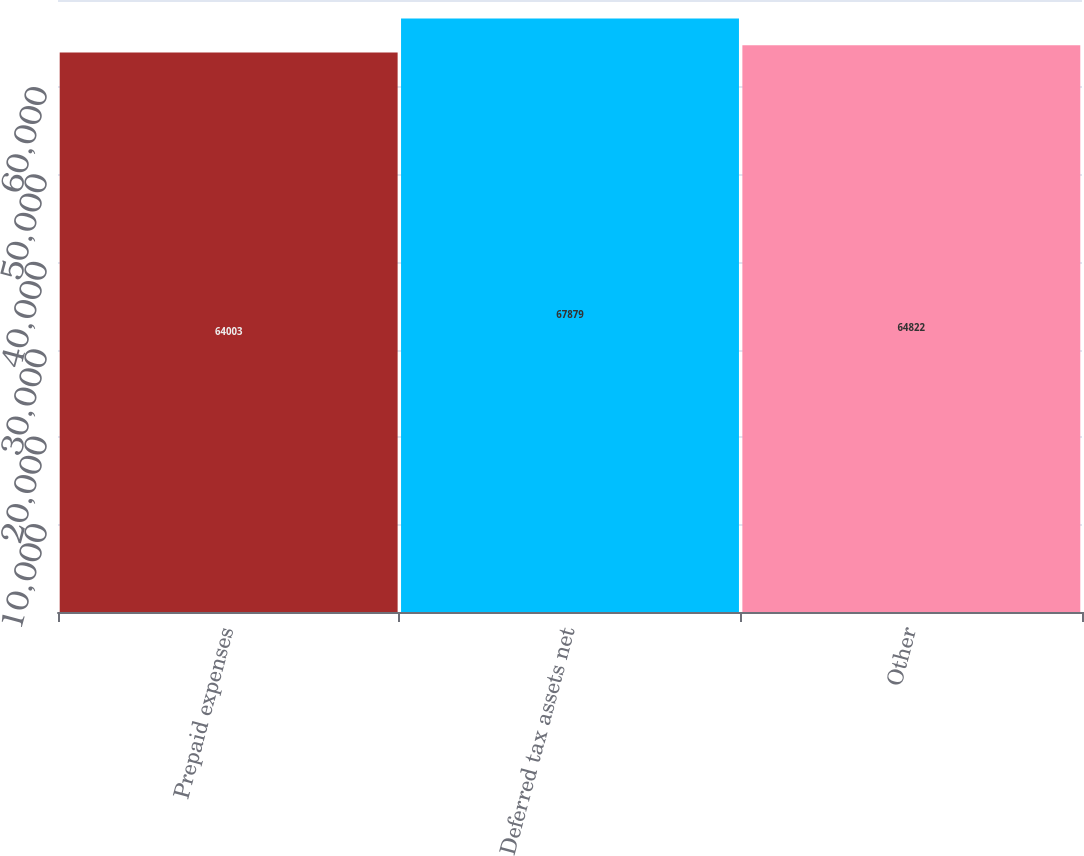Convert chart. <chart><loc_0><loc_0><loc_500><loc_500><bar_chart><fcel>Prepaid expenses<fcel>Deferred tax assets net<fcel>Other<nl><fcel>64003<fcel>67879<fcel>64822<nl></chart> 